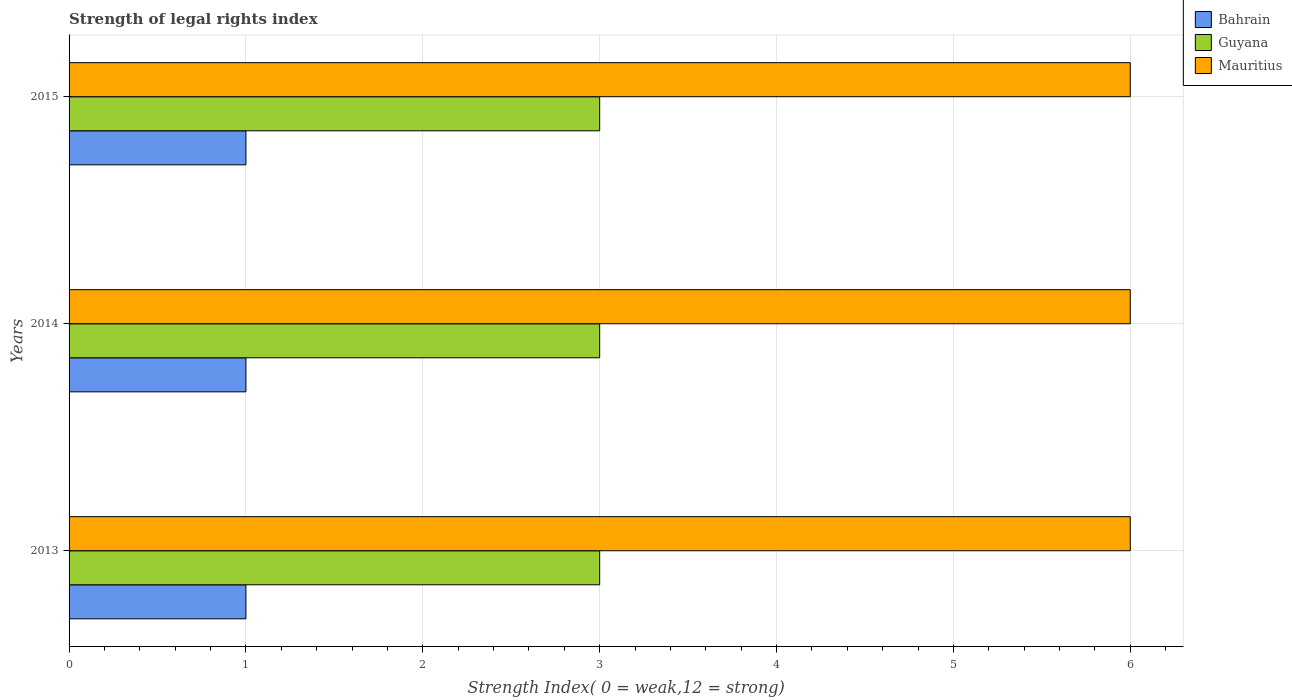How many different coloured bars are there?
Ensure brevity in your answer.  3. Are the number of bars per tick equal to the number of legend labels?
Provide a short and direct response. Yes. Are the number of bars on each tick of the Y-axis equal?
Make the answer very short. Yes. How many bars are there on the 3rd tick from the top?
Your response must be concise. 3. What is the label of the 1st group of bars from the top?
Offer a terse response. 2015. What is the strength index in Guyana in 2015?
Your response must be concise. 3. Across all years, what is the maximum strength index in Bahrain?
Your answer should be very brief. 1. In which year was the strength index in Guyana maximum?
Offer a very short reply. 2013. In which year was the strength index in Guyana minimum?
Provide a succinct answer. 2013. What is the total strength index in Mauritius in the graph?
Make the answer very short. 18. What is the difference between the strength index in Guyana in 2014 and that in 2015?
Your response must be concise. 0. What is the difference between the strength index in Bahrain in 2014 and the strength index in Guyana in 2015?
Offer a very short reply. -2. In the year 2014, what is the difference between the strength index in Guyana and strength index in Bahrain?
Offer a very short reply. 2. What is the ratio of the strength index in Guyana in 2013 to that in 2015?
Make the answer very short. 1. Is the strength index in Bahrain in 2014 less than that in 2015?
Your answer should be very brief. No. What is the difference between the highest and the second highest strength index in Mauritius?
Offer a very short reply. 0. What does the 1st bar from the top in 2013 represents?
Your response must be concise. Mauritius. What does the 2nd bar from the bottom in 2015 represents?
Provide a short and direct response. Guyana. How many bars are there?
Ensure brevity in your answer.  9. Are all the bars in the graph horizontal?
Make the answer very short. Yes. Are the values on the major ticks of X-axis written in scientific E-notation?
Offer a terse response. No. Does the graph contain any zero values?
Provide a succinct answer. No. Does the graph contain grids?
Offer a terse response. Yes. Where does the legend appear in the graph?
Your response must be concise. Top right. How are the legend labels stacked?
Keep it short and to the point. Vertical. What is the title of the graph?
Ensure brevity in your answer.  Strength of legal rights index. What is the label or title of the X-axis?
Keep it short and to the point. Strength Index( 0 = weak,12 = strong). What is the label or title of the Y-axis?
Ensure brevity in your answer.  Years. What is the Strength Index( 0 = weak,12 = strong) in Bahrain in 2013?
Keep it short and to the point. 1. What is the Strength Index( 0 = weak,12 = strong) in Mauritius in 2013?
Keep it short and to the point. 6. What is the Strength Index( 0 = weak,12 = strong) in Mauritius in 2014?
Ensure brevity in your answer.  6. What is the Strength Index( 0 = weak,12 = strong) of Bahrain in 2015?
Provide a succinct answer. 1. What is the Strength Index( 0 = weak,12 = strong) in Guyana in 2015?
Provide a short and direct response. 3. Across all years, what is the maximum Strength Index( 0 = weak,12 = strong) of Guyana?
Ensure brevity in your answer.  3. Across all years, what is the minimum Strength Index( 0 = weak,12 = strong) of Guyana?
Offer a very short reply. 3. Across all years, what is the minimum Strength Index( 0 = weak,12 = strong) of Mauritius?
Provide a succinct answer. 6. What is the total Strength Index( 0 = weak,12 = strong) in Guyana in the graph?
Keep it short and to the point. 9. What is the total Strength Index( 0 = weak,12 = strong) in Mauritius in the graph?
Offer a very short reply. 18. What is the difference between the Strength Index( 0 = weak,12 = strong) of Bahrain in 2013 and that in 2014?
Your answer should be very brief. 0. What is the difference between the Strength Index( 0 = weak,12 = strong) of Guyana in 2013 and that in 2014?
Your answer should be compact. 0. What is the difference between the Strength Index( 0 = weak,12 = strong) of Guyana in 2013 and that in 2015?
Your answer should be compact. 0. What is the difference between the Strength Index( 0 = weak,12 = strong) of Mauritius in 2013 and that in 2015?
Your answer should be very brief. 0. What is the difference between the Strength Index( 0 = weak,12 = strong) of Bahrain in 2014 and that in 2015?
Provide a succinct answer. 0. What is the difference between the Strength Index( 0 = weak,12 = strong) of Guyana in 2014 and that in 2015?
Ensure brevity in your answer.  0. What is the difference between the Strength Index( 0 = weak,12 = strong) in Bahrain in 2013 and the Strength Index( 0 = weak,12 = strong) in Guyana in 2014?
Give a very brief answer. -2. What is the difference between the Strength Index( 0 = weak,12 = strong) in Bahrain in 2013 and the Strength Index( 0 = weak,12 = strong) in Guyana in 2015?
Your response must be concise. -2. What is the difference between the Strength Index( 0 = weak,12 = strong) of Guyana in 2013 and the Strength Index( 0 = weak,12 = strong) of Mauritius in 2015?
Provide a succinct answer. -3. What is the average Strength Index( 0 = weak,12 = strong) in Guyana per year?
Provide a succinct answer. 3. What is the average Strength Index( 0 = weak,12 = strong) in Mauritius per year?
Offer a very short reply. 6. In the year 2013, what is the difference between the Strength Index( 0 = weak,12 = strong) in Bahrain and Strength Index( 0 = weak,12 = strong) in Mauritius?
Give a very brief answer. -5. In the year 2013, what is the difference between the Strength Index( 0 = weak,12 = strong) in Guyana and Strength Index( 0 = weak,12 = strong) in Mauritius?
Offer a very short reply. -3. In the year 2014, what is the difference between the Strength Index( 0 = weak,12 = strong) of Bahrain and Strength Index( 0 = weak,12 = strong) of Mauritius?
Ensure brevity in your answer.  -5. In the year 2015, what is the difference between the Strength Index( 0 = weak,12 = strong) in Bahrain and Strength Index( 0 = weak,12 = strong) in Guyana?
Your answer should be very brief. -2. In the year 2015, what is the difference between the Strength Index( 0 = weak,12 = strong) of Bahrain and Strength Index( 0 = weak,12 = strong) of Mauritius?
Your answer should be compact. -5. What is the ratio of the Strength Index( 0 = weak,12 = strong) in Guyana in 2013 to that in 2014?
Offer a very short reply. 1. What is the ratio of the Strength Index( 0 = weak,12 = strong) of Bahrain in 2013 to that in 2015?
Make the answer very short. 1. What is the ratio of the Strength Index( 0 = weak,12 = strong) of Guyana in 2013 to that in 2015?
Your answer should be very brief. 1. What is the ratio of the Strength Index( 0 = weak,12 = strong) in Guyana in 2014 to that in 2015?
Your answer should be compact. 1. What is the ratio of the Strength Index( 0 = weak,12 = strong) in Mauritius in 2014 to that in 2015?
Your answer should be compact. 1. What is the difference between the highest and the second highest Strength Index( 0 = weak,12 = strong) in Bahrain?
Provide a succinct answer. 0. What is the difference between the highest and the second highest Strength Index( 0 = weak,12 = strong) in Guyana?
Offer a very short reply. 0. What is the difference between the highest and the second highest Strength Index( 0 = weak,12 = strong) of Mauritius?
Ensure brevity in your answer.  0. What is the difference between the highest and the lowest Strength Index( 0 = weak,12 = strong) of Bahrain?
Keep it short and to the point. 0. What is the difference between the highest and the lowest Strength Index( 0 = weak,12 = strong) in Guyana?
Provide a succinct answer. 0. What is the difference between the highest and the lowest Strength Index( 0 = weak,12 = strong) in Mauritius?
Your answer should be very brief. 0. 